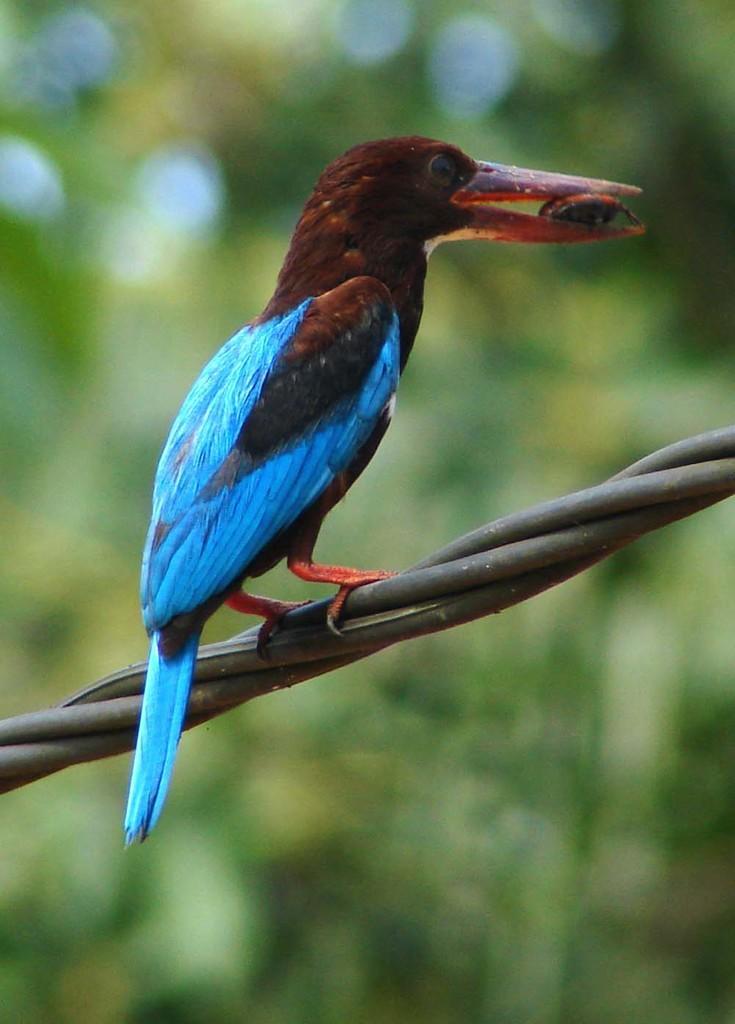Can you describe this image briefly? In the center of the image there is a bird on the cable. The background of the image is blur. 